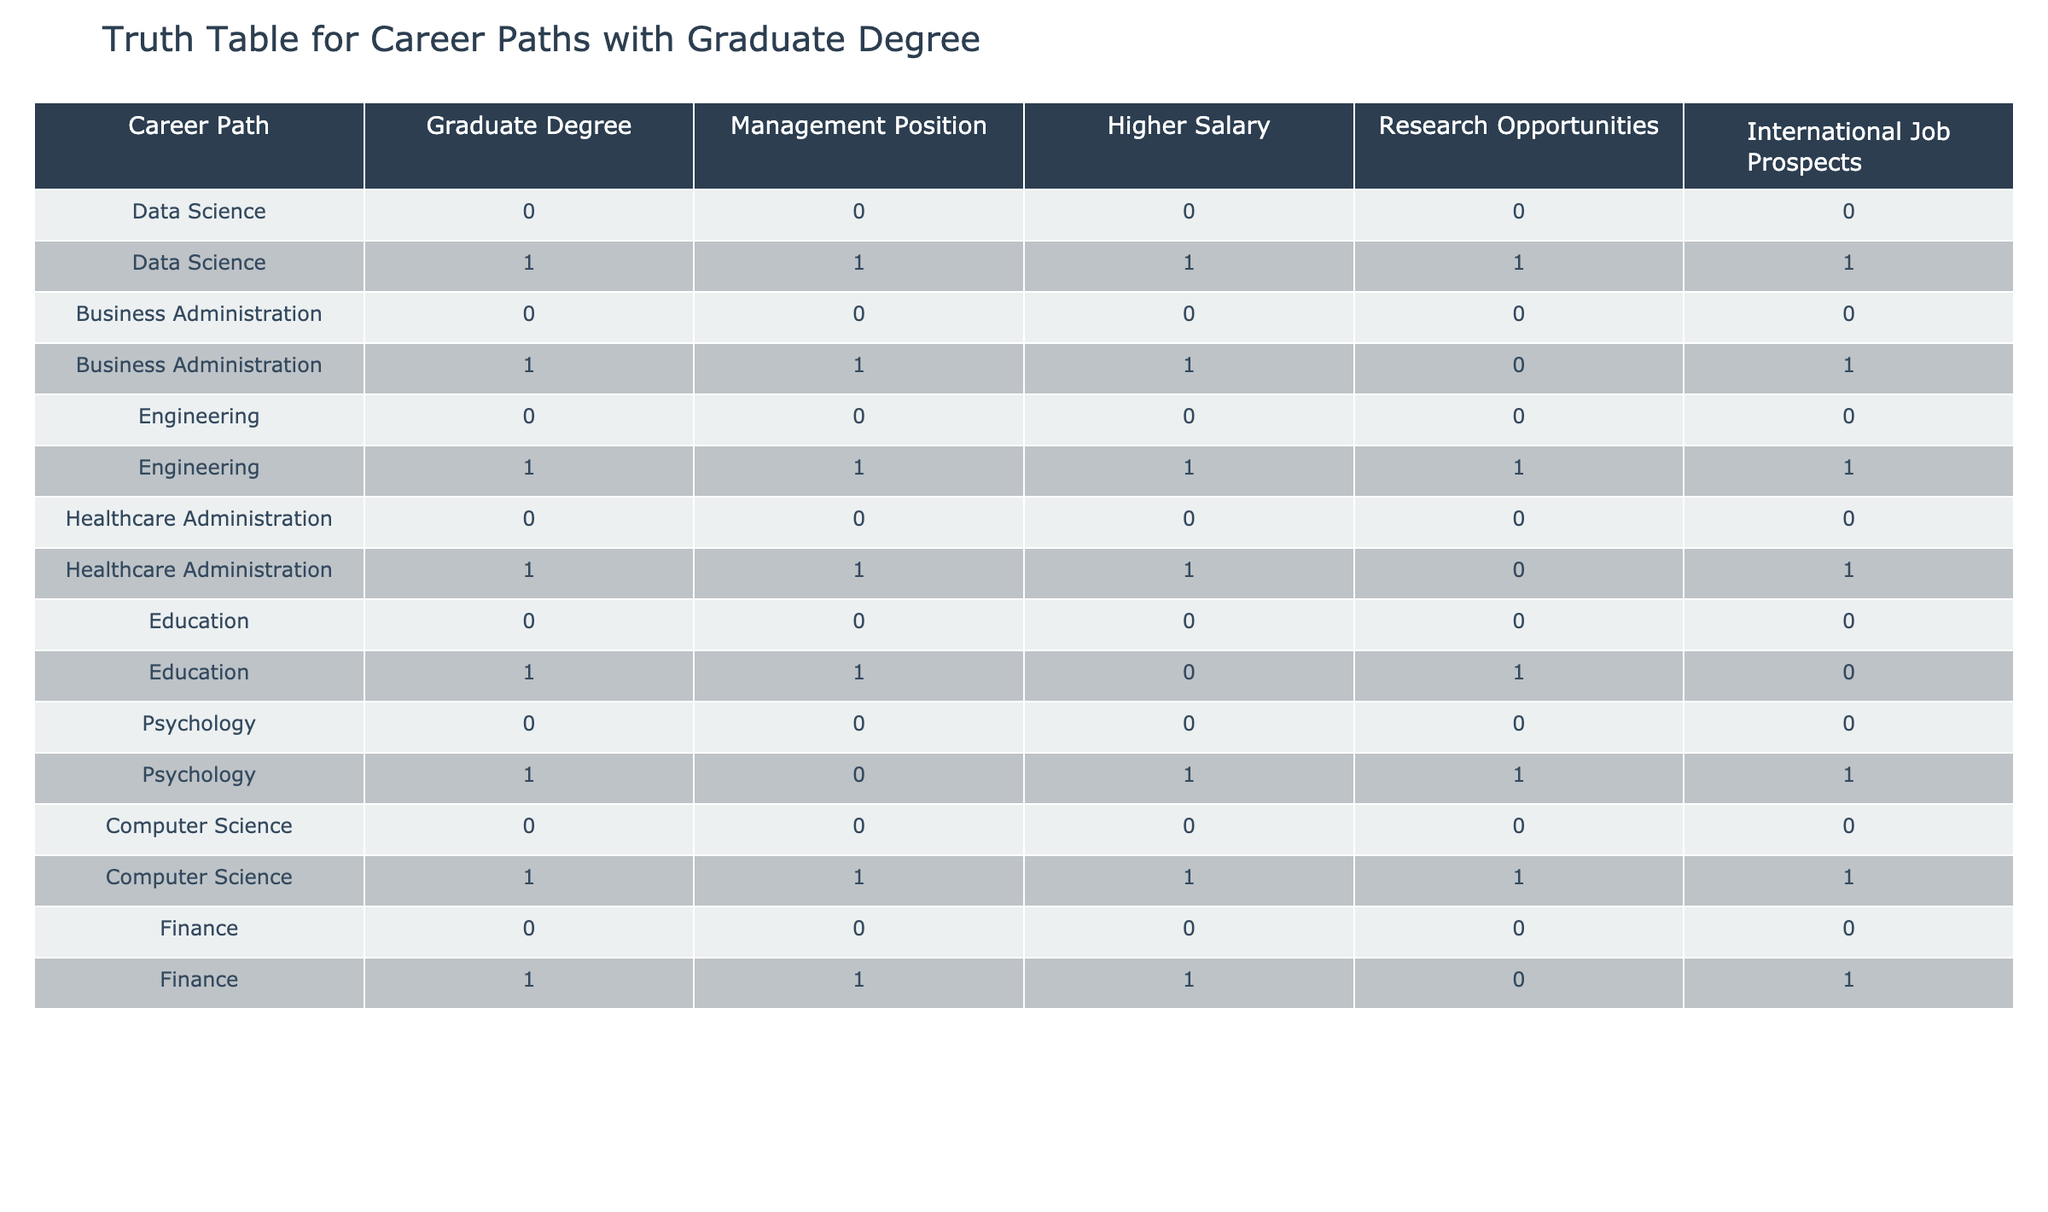What career paths offer higher salaries with a graduate degree? Looking at the table, the careers with a graduate degree that offer higher salaries are Data Science, Business Administration, Engineering, Computer Science, and Finance.
Answer: Data Science, Business Administration, Engineering, Computer Science, Finance Is a graduate degree necessary for a management position in Data Science? According to the table, Data Science has management positions available only for those with a graduate degree. Therefore, it is necessary for a management position in this field.
Answer: Yes Which career path has the most significant research opportunities without a graduate degree? The table shows that all careers listed do not provide research opportunities without a graduate degree, as each has '0' in the Research Opportunities column for that case.
Answer: None How many career paths have both international job prospects and management positions with a graduate degree? The rows showing a graduate degree indicate that Data Science, Business Administration, Engineering, and Finance offer both international job prospects and management positions. Thus, there are four career paths that satisfy this condition.
Answer: Four Is obtaining a graduate degree beneficial for pursuing a career in Psychology in terms of management positions? The table indicates that psychology does not provide management positions with a graduate degree, as it shows '0' in the Management Position column for that category. Thus, it does not offer a management position even with a graduate degree.
Answer: No What is the total number of career paths in the table that offer research opportunities? Upon examining the table, the careers that offer research opportunities with a graduate degree are Data Science, Engineering, and Psychology. Counting those gives a total of three career paths with research opportunities.
Answer: Three If a person has a graduate degree, what career paths ensure all benefits (management position, higher salary, research opportunities, international job prospects)? The table indicates that Data Science, Engineering, and Computer Science provide all benefits with a graduate degree, having '1' across all categories in the respective rows.
Answer: Data Science, Engineering, Computer Science Are there any career paths that provide both higher salary and research opportunities without a graduate degree? According to the data presented, none of the career paths provide both higher salary and research opportunities without a graduate degree since all relevant cases have '0' for those conditions.
Answer: No 